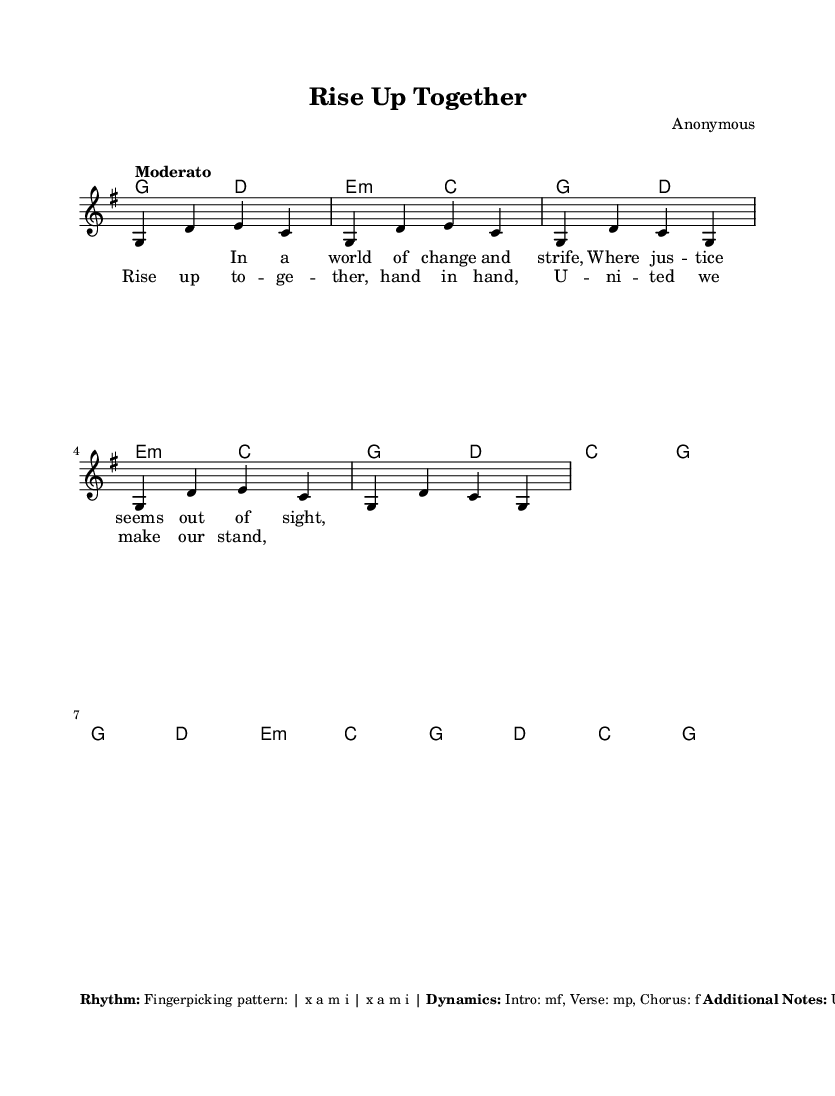What is the key signature of this music? The key signature is indicated at the beginning of the piece and shows one sharp, which is F#. This corresponds to G major.
Answer: G major What is the time signature of this music? The time signature is found at the start of the piece, showing a 4 over 4. This indicates four beats per measure, or quarter note gets the beat.
Answer: 4/4 What is the tempo marking for this piece? The tempo is described in Italian notation, which specifies the speed of the piece as "Moderato," suggesting a moderate pace.
Answer: Moderato How many measures are in the chorus? The chorus is identified separately and consists of two sets of melodic lines, each being 4 counts long, indicating a total of 4 measures.
Answer: 4 What dynamic marking is indicated for the chorus? The dynamic marking for the chorus suggests a loud intensity, marked "f" which stands for forte, indicating strong emphasis during that part.
Answer: f What emotional delivery is suggested for the vocals? The additional notes indicate that emotional delivery is crucial, emphasizing that singers should focus on conveying strong feelings through their performance during the song.
Answer: Emotional delivery How does the folk style influence the chord progression in this piece? The use of simple, repetitive chord patterns is characteristic of folk music, emphasizing sing-along qualities, and highlighting a communal feeling reflected in the lyrics about unity and justice.
Answer: Sing-along qualities 